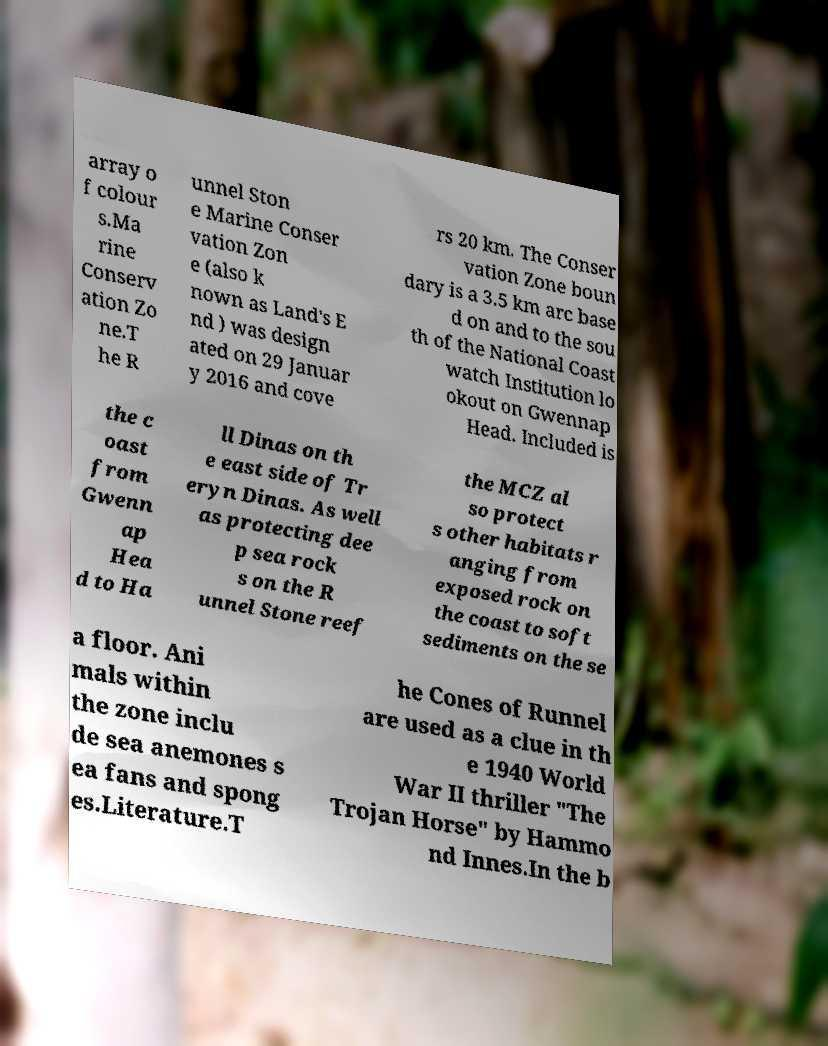Could you assist in decoding the text presented in this image and type it out clearly? array o f colour s.Ma rine Conserv ation Zo ne.T he R unnel Ston e Marine Conser vation Zon e (also k nown as Land's E nd ) was design ated on 29 Januar y 2016 and cove rs 20 km. The Conser vation Zone boun dary is a 3.5 km arc base d on and to the sou th of the National Coast watch Institution lo okout on Gwennap Head. Included is the c oast from Gwenn ap Hea d to Ha ll Dinas on th e east side of Tr eryn Dinas. As well as protecting dee p sea rock s on the R unnel Stone reef the MCZ al so protect s other habitats r anging from exposed rock on the coast to soft sediments on the se a floor. Ani mals within the zone inclu de sea anemones s ea fans and spong es.Literature.T he Cones of Runnel are used as a clue in th e 1940 World War II thriller "The Trojan Horse" by Hammo nd Innes.In the b 